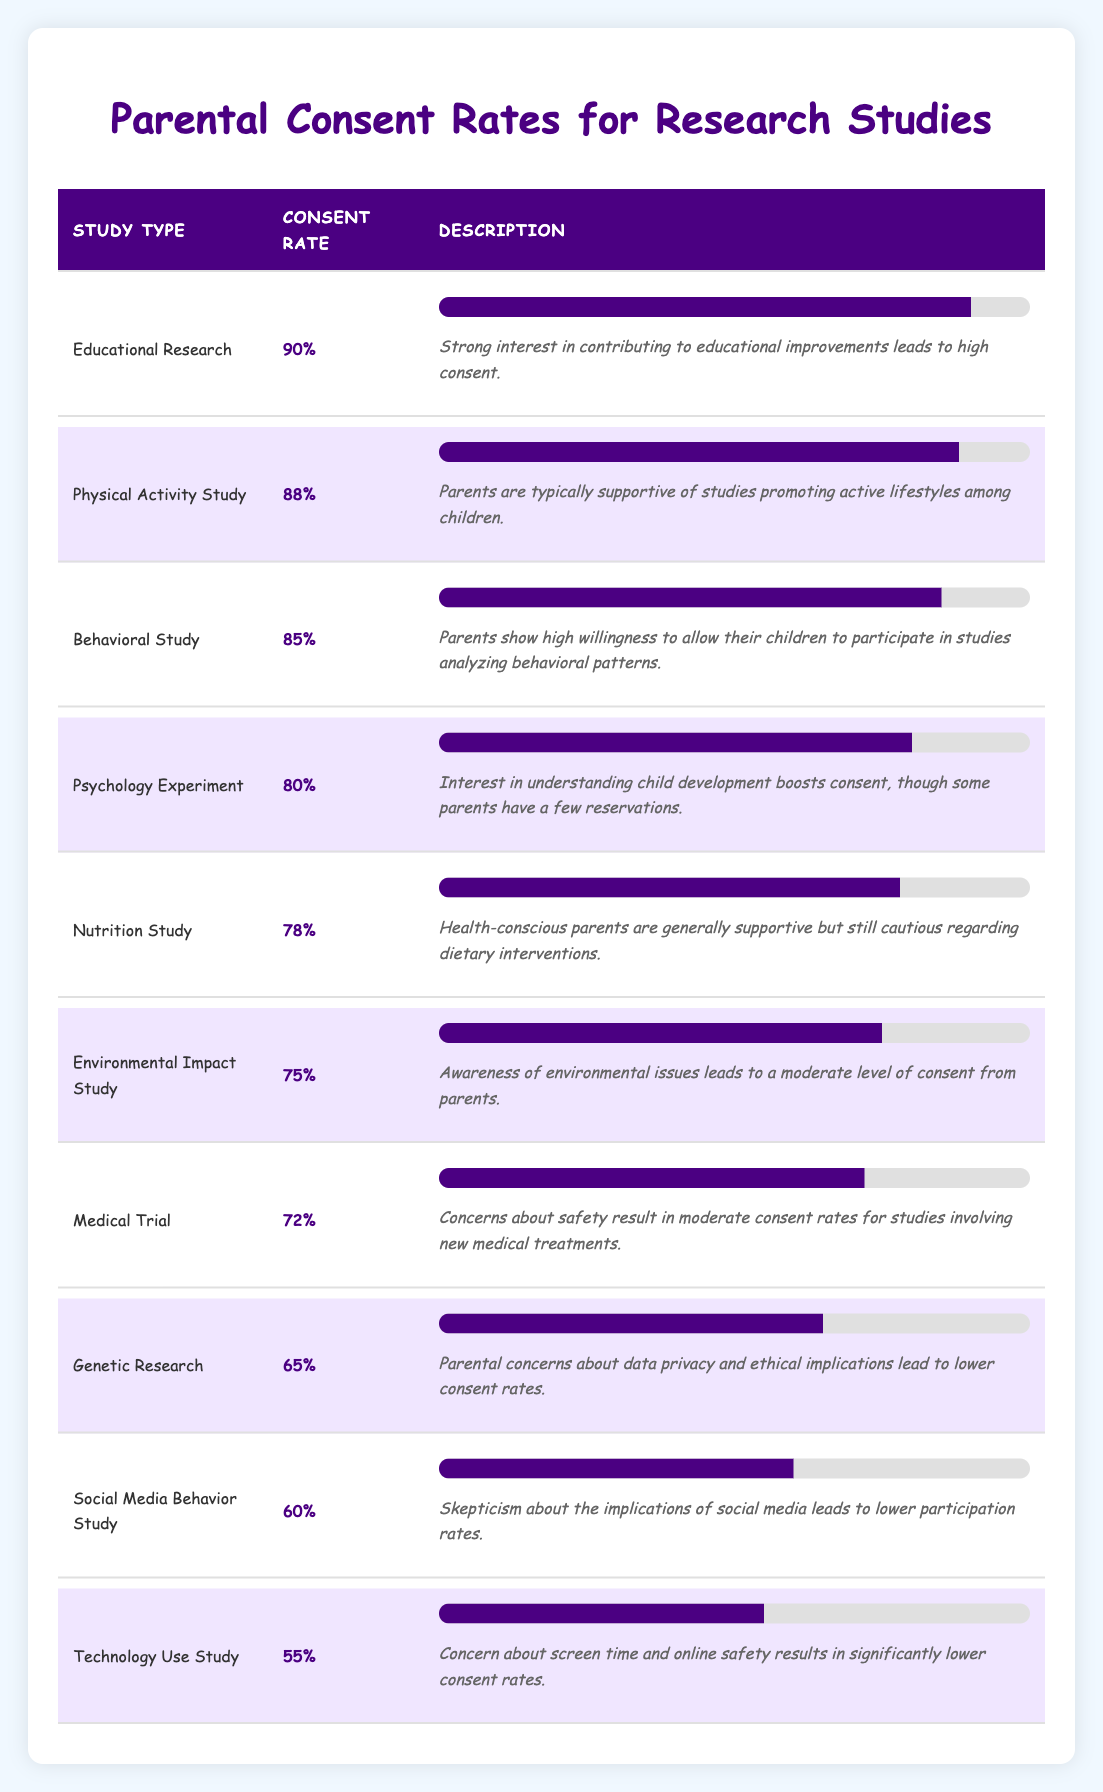What is the consent rate for Educational Research? The table lists Educational Research under the study type, showing a consent rate of 90%.
Answer: 90% Which study type has the highest parental consent rate? By reviewing the consent rates, I see that Educational Research has the highest consent rate of 90%.
Answer: Educational Research What is the average consent rate for Behavioral Study, Nutrition Study, and Physical Activity Study? I will first find the consent rates: Behavioral Study is 85%, Nutrition Study is 78%, and Physical Activity Study is 88%. To calculate the average: (85 + 78 + 88) / 3 = 250 / 3 = approximately 83.33.
Answer: 83.33 Is it true that the consent rate for Technology Use Study is higher than that for Social Media Behavior Study? Comparing the consent rates, Technology Use Study has a consent rate of 55% while Social Media Behavior Study has 60%. Therefore, this statement is false.
Answer: No What is the difference in consent rates between Genetic Research and Medical Trial? I check the rates: Genetic Research is 65% and Medical Trial is 72%. The difference is 72 - 65 = 7%.
Answer: 7% Which studies have consent rates below 70%? The consent rates below 70% belong to Genetic Research (65%), Social Media Behavior Study (60%), and Technology Use Study (55%).
Answer: Genetic Research, Social Media Behavior Study, Technology Use Study If parents are more cautious, would they likely consent less to studies involving genetics compared to education? Yes, based on the consent rates, Genetic Research is at 65%, which is significantly lower than the 90% for Educational Research, suggesting that concerns about genetics lead to less consent.
Answer: Yes How many study types have a consent rate of 80% or higher? The study types with rates of 80% or higher are Educational Research (90%), Physical Activity Study (88%), Behavioral Study (85%), and Psychology Experiment (80%). That is a total of 4 study types.
Answer: 4 What can be inferred if the consent rate for Medical Trials is significantly lower than that for Physical Activity Studies? Medical Trials have a consent rate of 72%, while Physical Activity Studies have 88%. This indicates that parents may feel more apprehensive about new medical treatments than activities promoting health, reflecting their priority for safety.
Answer: Parents prioritize safety 